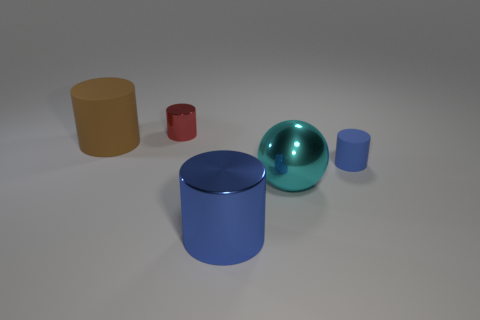How many yellow objects are small rubber cubes or big spheres?
Your answer should be very brief. 0. Are there any tiny cyan metallic blocks?
Provide a short and direct response. No. Is there a red shiny cylinder that is in front of the small cylinder on the right side of the big cylinder right of the brown object?
Provide a succinct answer. No. Is the shape of the cyan metallic thing the same as the big brown matte object behind the small matte cylinder?
Your answer should be very brief. No. There is a matte thing that is behind the small cylinder on the right side of the metallic thing behind the brown cylinder; what is its color?
Offer a terse response. Brown. What number of objects are big cyan shiny balls that are behind the blue metallic cylinder or metal cylinders that are behind the large cyan thing?
Provide a succinct answer. 2. What number of other objects are the same color as the ball?
Your answer should be compact. 0. Do the tiny object that is in front of the large brown matte cylinder and the brown rubber object have the same shape?
Give a very brief answer. Yes. Is the number of brown things that are in front of the big shiny sphere less than the number of cyan things?
Your answer should be compact. Yes. Are there any blue cylinders made of the same material as the brown object?
Offer a very short reply. Yes. 